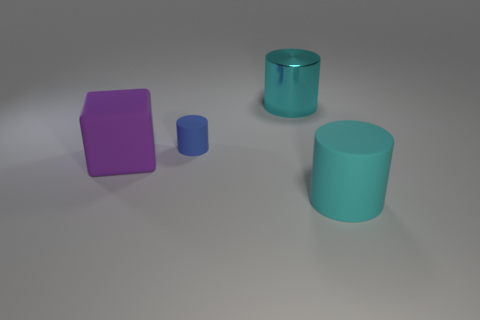There is a large matte object that is the same shape as the cyan shiny thing; what is its color?
Your response must be concise. Cyan. There is a big thing behind the big cube; how many purple matte objects are right of it?
Your response must be concise. 0. What number of blocks are either big cyan rubber things or big objects?
Give a very brief answer. 1. Is there a big cyan rubber thing?
Offer a very short reply. Yes. There is another cyan thing that is the same shape as the big metallic object; what is its size?
Offer a very short reply. Large. There is a cyan object that is behind the cyan thing that is on the right side of the cyan shiny object; what shape is it?
Offer a very short reply. Cylinder. What number of yellow objects are rubber blocks or big shiny cylinders?
Provide a short and direct response. 0. What color is the tiny rubber object?
Provide a succinct answer. Blue. Does the cyan shiny thing have the same size as the purple matte object?
Provide a succinct answer. Yes. Is there any other thing that has the same shape as the shiny object?
Give a very brief answer. Yes. 